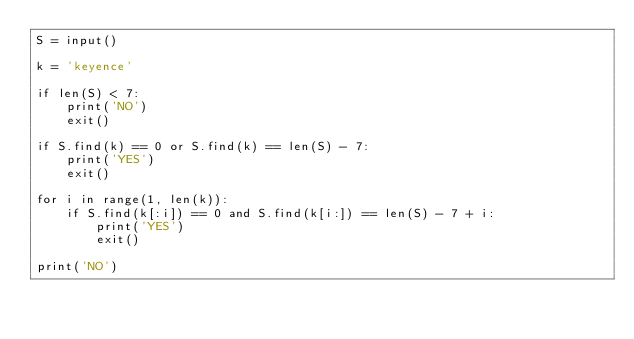Convert code to text. <code><loc_0><loc_0><loc_500><loc_500><_Python_>S = input()

k = 'keyence'

if len(S) < 7:
    print('NO')
    exit()

if S.find(k) == 0 or S.find(k) == len(S) - 7:
    print('YES')
    exit()

for i in range(1, len(k)):
    if S.find(k[:i]) == 0 and S.find(k[i:]) == len(S) - 7 + i:
        print('YES')
        exit()

print('NO')

</code> 